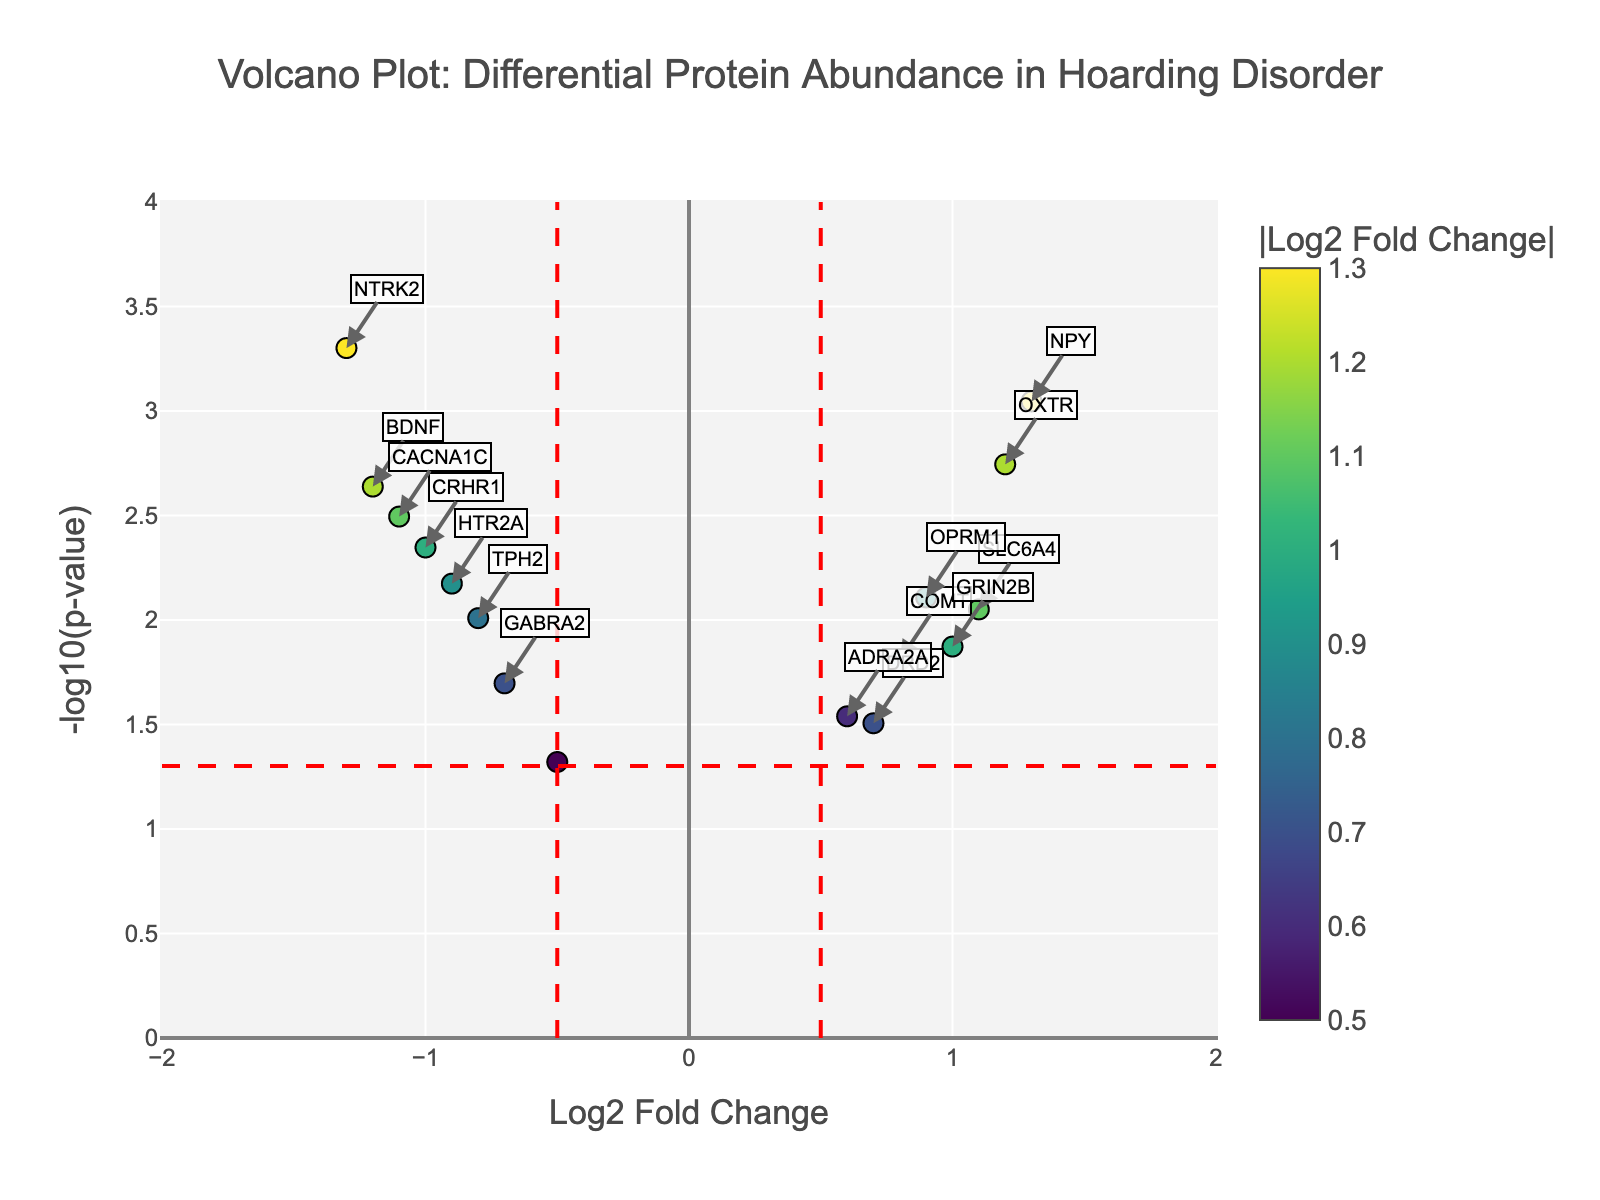How is the significance of a protein measured in the plot? The significance of a protein is measured using the -log10(pValue). Higher values on the y-axis indicate more significant results.
Answer: -log10(pValue) What is the title of the plot? The title is displayed at the top of the plot, indicating the focus of the analysis.
Answer: "Volcano Plot: Differential Protein Abundance in Hoarding Disorder" How many proteins show a log2 fold change greater than 1? By looking at the x-axis, count the number of points to the right of the +1 mark. Proteins with log2 fold change greater than 1 are SLC6A4, OXTR, NPY.
Answer: 3 Which protein has the highest significance? By looking at the highest point on the y-axis (+log10(pValue)), the protein with the highest value is NTRK2.
Answer: NTRK2 What does a negative log2 fold change indicate? A negative log2 fold change means the protein is less abundant in individuals with hoarding tendencies compared to those without.
Answer: Less abundant in hoarding individuals Which protein has the highest positive log2 fold change? By finding the point furthest to the right on the x-axis, the protein with the highest positive log2 fold change is NPY.
Answer: NPY What are the threshold lines for in the plot? The threshold lines indicate significance levels. The vertical lines show log2 fold change thresholds of ±0.5, and the horizontal line shows a p-value threshold (usually 0.05).
Answer: Significance levels Which proteins are labeled on the plot? Proteins that have a log2 fold change above 0.5 and a p-value below 0.05 are labeled. These include BDNF, NTRK2, OXTR, NPY, CACNA1C, CRHR1, HTR2A, TPH2, and MAOA.
Answer: BDNF, NTRK2, OXTR, NPY, CACNA1C, CRHR1, HTR2A, TPH2, MAOA Which protein has the smallest p-value? The protein with the smallest p-value will have the highest point on the y-axis (-log10(p-value)), which is NTRK2.
Answer: NTRK2 